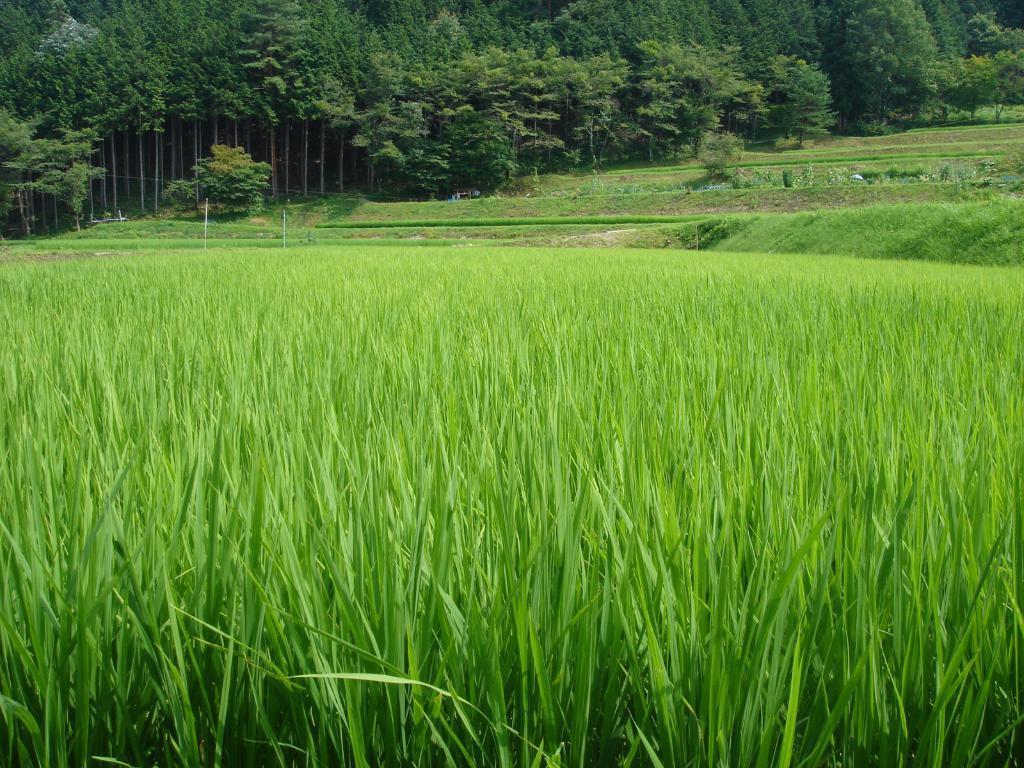Describe this image in one or two sentences. In this picture we can see the fields. At the top of the image we can see the trees. 